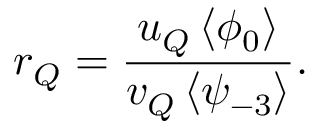Convert formula to latex. <formula><loc_0><loc_0><loc_500><loc_500>r _ { Q } = \frac { u _ { Q } \left < \phi _ { 0 } \right > } { v _ { Q } \left < \psi _ { - 3 } \right > } .</formula> 